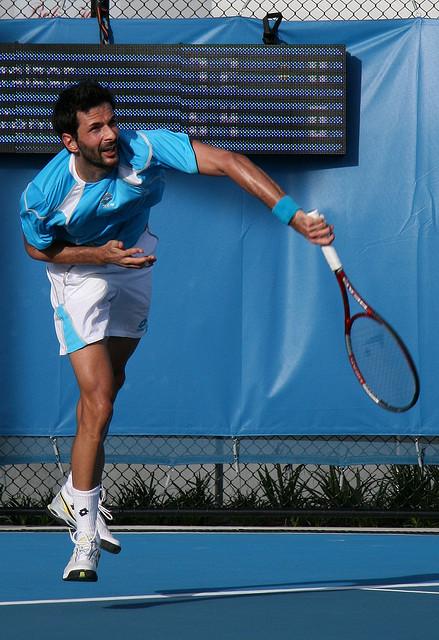What color are his shoes?
Keep it brief. White. What color is the fence behind him?
Write a very short answer. Blue. What brand are the socks?
Quick response, please. Under armour. What sport is he playing?
Quick response, please. Tennis. What color is the strip on the boy's shirt?
Concise answer only. White. Are the man's feet on the ground?
Short answer required. No. What color is his shirt?
Write a very short answer. Blue. Which hand is holding the handle of the tennis racket?
Keep it brief. Left. 